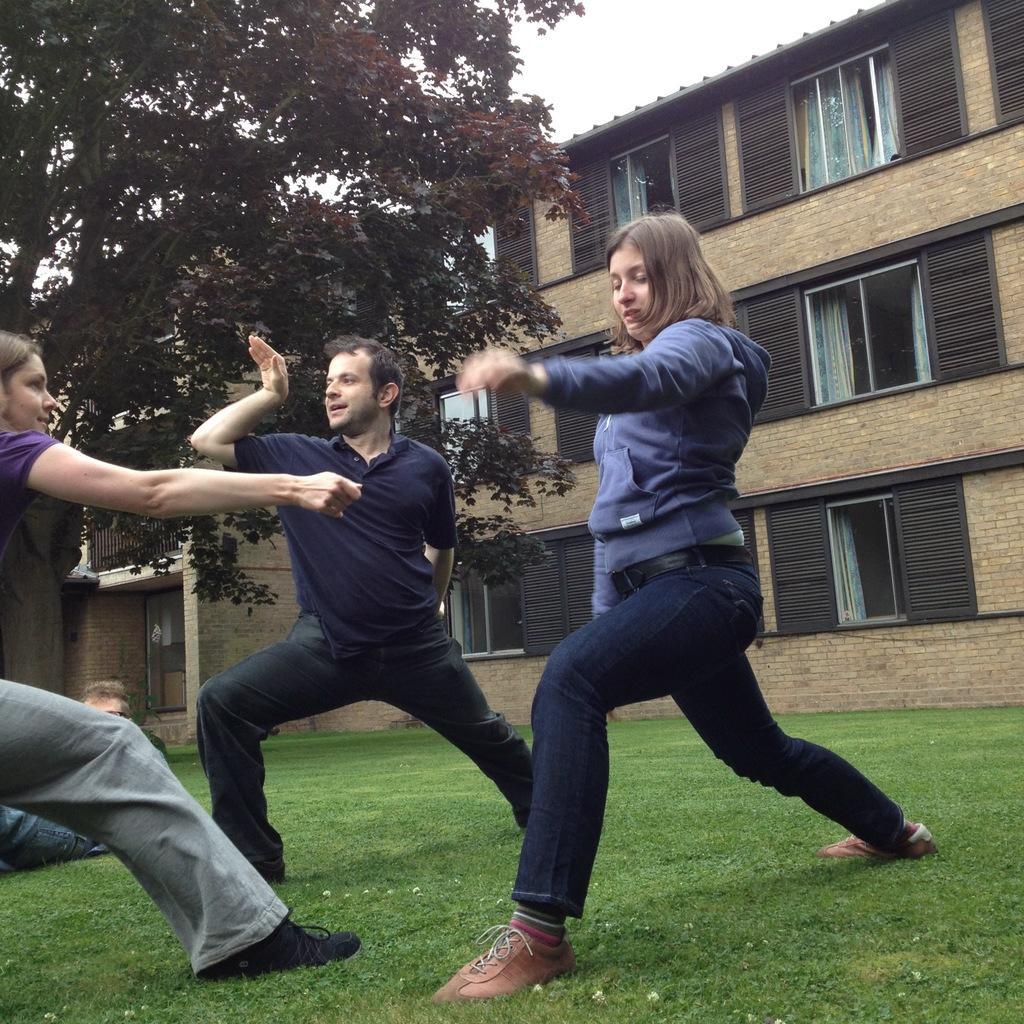In one or two sentences, can you explain what this image depicts? This picture is clicked outside. In the center we can see the group of people seems to be doing some actions. In the background we can see the green grass, buildings, sky and trees. 